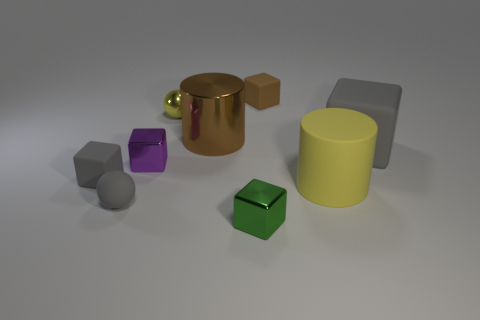There is a matte thing that is the same color as the large metal thing; what size is it?
Offer a terse response. Small. There is a tiny object that is the same color as the big rubber cylinder; what is its shape?
Your response must be concise. Sphere. There is a gray block to the left of the big gray matte block; what is its material?
Provide a short and direct response. Rubber. Does the yellow rubber thing have the same shape as the purple object?
Your answer should be compact. No. There is a block in front of the rubber cube left of the tiny gray sphere that is in front of the big brown thing; what color is it?
Your answer should be compact. Green. What number of other matte objects are the same shape as the small yellow object?
Keep it short and to the point. 1. There is a cylinder to the left of the cylinder on the right side of the big brown object; what size is it?
Your answer should be compact. Large. Does the purple metallic block have the same size as the brown shiny thing?
Your answer should be very brief. No. There is a gray rubber thing to the right of the small block behind the small metal sphere; is there a shiny thing that is in front of it?
Your answer should be very brief. Yes. The brown matte thing has what size?
Provide a succinct answer. Small. 